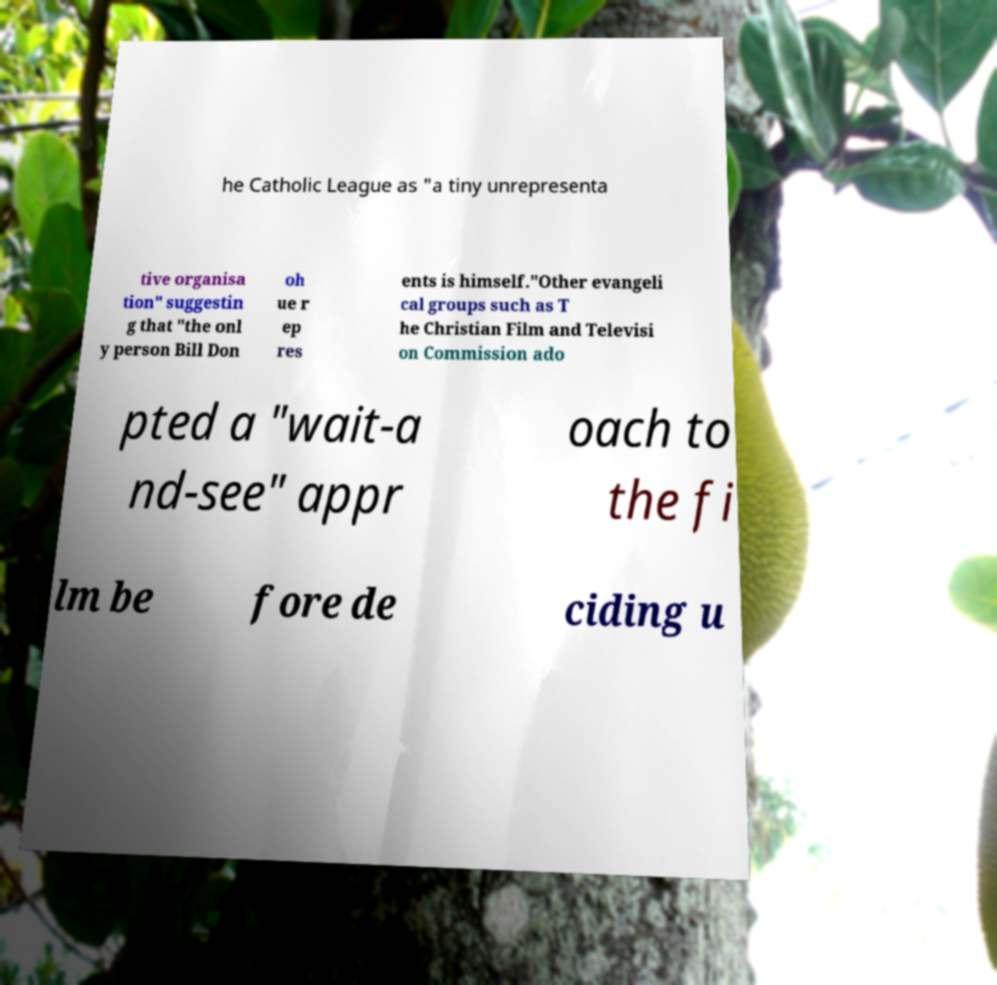Please identify and transcribe the text found in this image. he Catholic League as "a tiny unrepresenta tive organisa tion" suggestin g that "the onl y person Bill Don oh ue r ep res ents is himself."Other evangeli cal groups such as T he Christian Film and Televisi on Commission ado pted a "wait-a nd-see" appr oach to the fi lm be fore de ciding u 